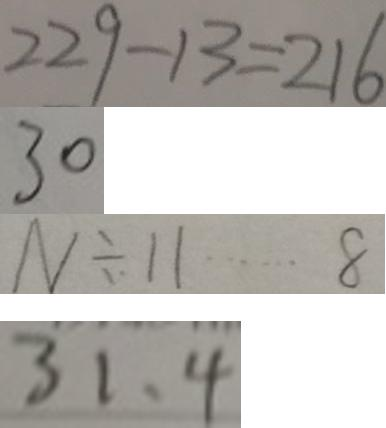<formula> <loc_0><loc_0><loc_500><loc_500>2 2 9 - 1 3 = 2 1 6 
 3 0 
 N \div 1 1 \cdots 8 
 3 1 、 4</formula> 